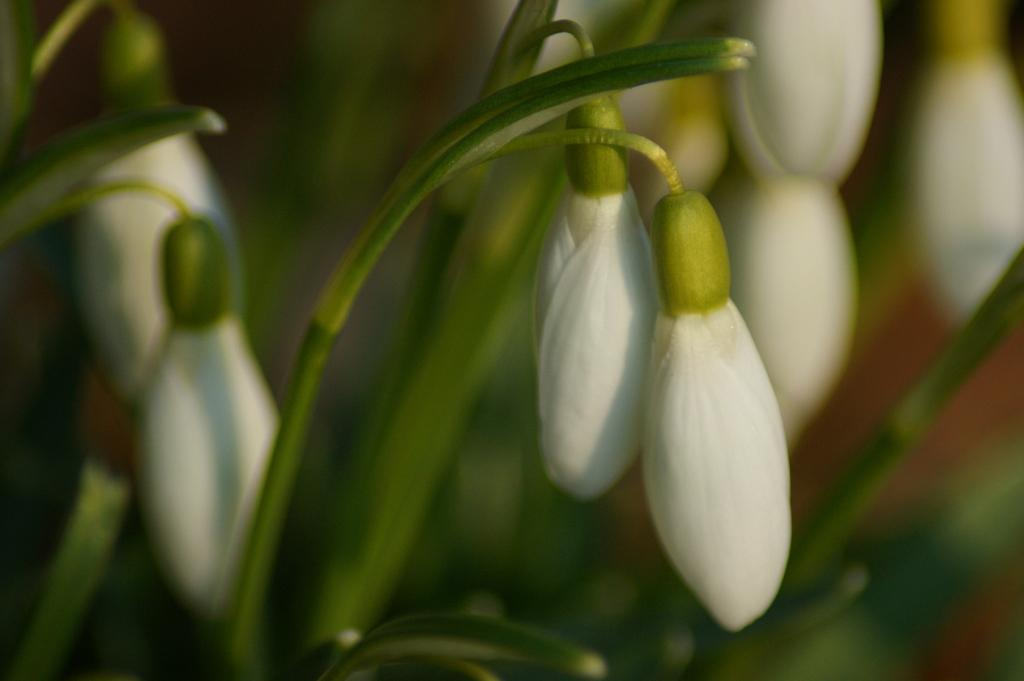What type of living organisms can be seen in the image? There are flowers and plants in the image. Can you describe the background of the image? The background of the image is blurred. What language is spoken by the spiders in the image? There are no spiders present in the image, so it is not possible to determine what language they might speak. 